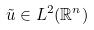Convert formula to latex. <formula><loc_0><loc_0><loc_500><loc_500>\tilde { u } \in L ^ { 2 } ( \mathbb { R } ^ { n } )</formula> 